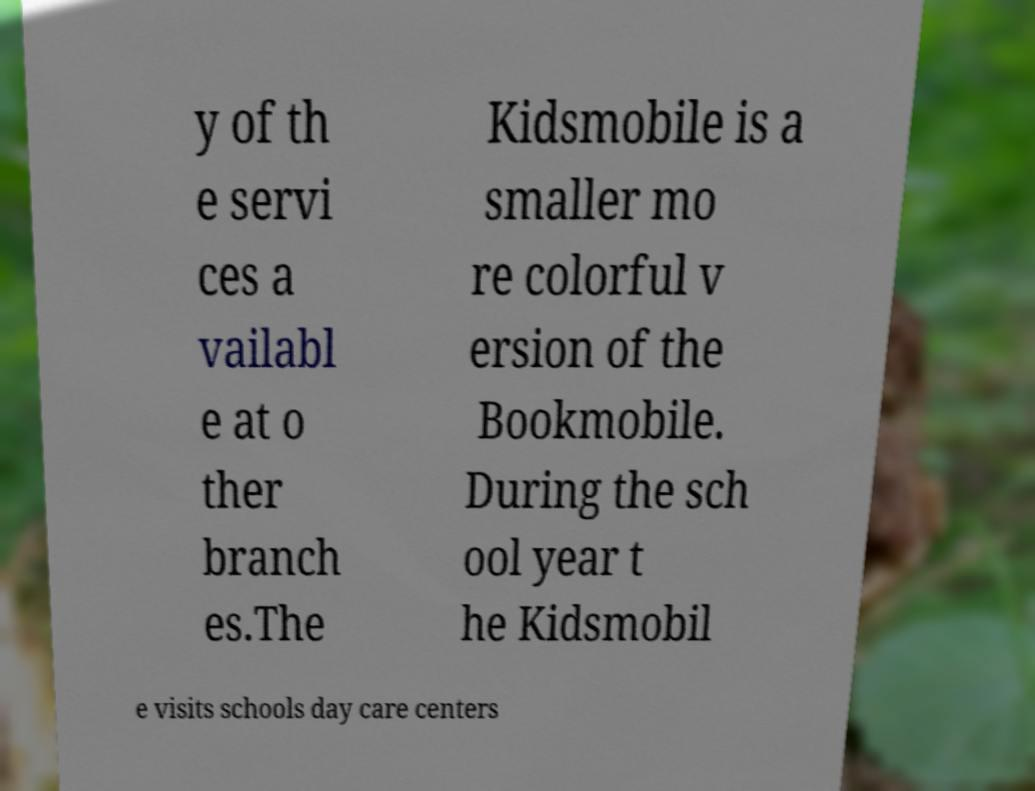Please read and relay the text visible in this image. What does it say? y of th e servi ces a vailabl e at o ther branch es.The Kidsmobile is a smaller mo re colorful v ersion of the Bookmobile. During the sch ool year t he Kidsmobil e visits schools day care centers 